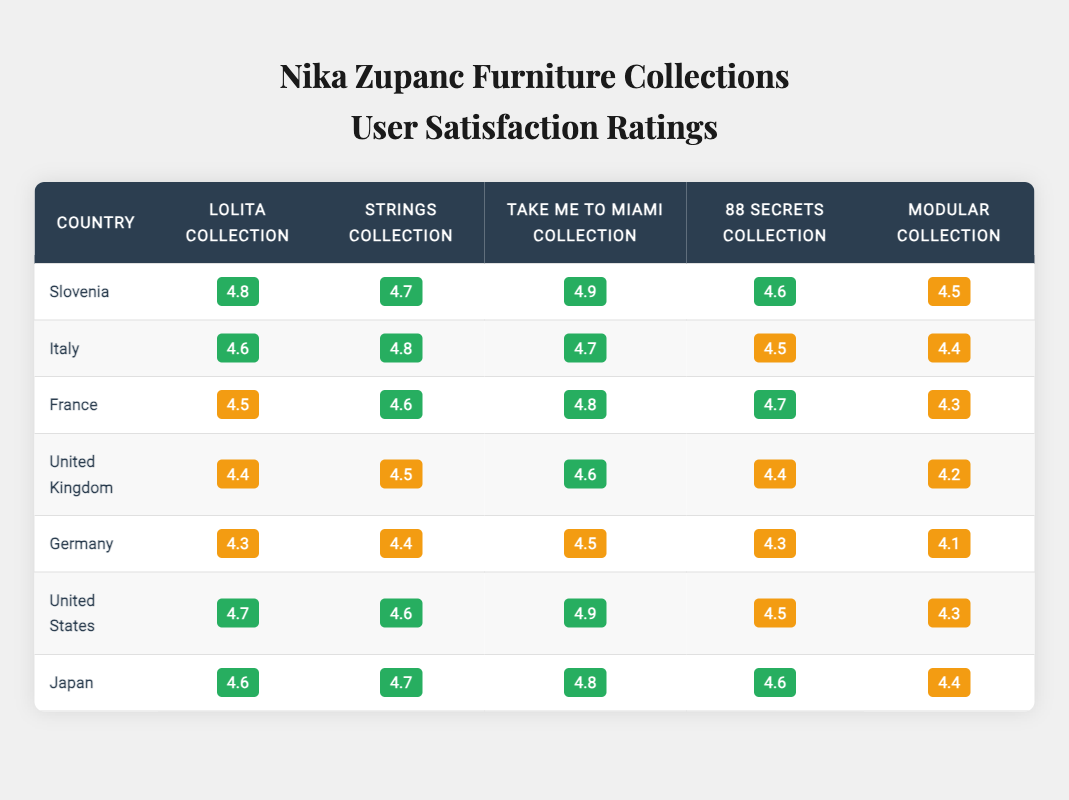What is the highest user satisfaction rating for the Lolita Collection? In the table, the ratings for the Lolita Collection across different countries are as follows: Slovenia (4.8), Italy (4.6), France (4.5), United Kingdom (4.4), Germany (4.3), United States (4.7), and Japan (4.6). The highest rating is 4.9, which is not listed for the Lolita Collection in any country; hence, Slovenia holds the highest score at 4.8.
Answer: 4.8 Which collection has the highest rating in France? In the table, the ratings for the collections in France are: Lolita Collection (4.5), Strings Collection (4.6), Take Me to Miami Collection (4.8), 88 Secrets Collection (4.7), and Modular Collection (4.3). The highest rating among these is the Take Me to Miami Collection with a score of 4.8.
Answer: Take Me to Miami Collection Is the user satisfaction rating for the Modular Collection in Germany higher than in the United Kingdom? The ratings for the Modular Collection are as follows: Germany (4.1) and United Kingdom (4.2). Since 4.1 is less than 4.2, the rating for the Modular Collection in Germany is not higher than in the United Kingdom.
Answer: No What is the average rating of the Strings Collection across all countries? The ratings for the Strings Collection are: Slovenia (4.7), Italy (4.8), France (4.6), United Kingdom (4.5), Germany (4.4), United States (4.6), and Japan (4.7). Summing these gives 4.7 + 4.8 + 4.6 + 4.5 + 4.4 + 4.6 + 4.7 = 32.3. There are 7 ratings, so the average is 32.3 / 7 ≈ 4.61.
Answer: 4.61 Which country has the lowest rating for the 88 Secrets Collection? Reviewing the ratings for the 88 Secrets Collection: Slovenia (4.6), Italy (4.5), France (4.7), United Kingdom (4.4), Germany (4.3), United States (4.5), and Japan (4.6), Germany has the lowest rating at 4.3.
Answer: Germany In which country did the Take Me to Miami Collection receive the highest rating? The ratings for the Take Me to Miami Collection are: Slovenia (4.9), Italy (4.7), France (4.8), United Kingdom (4.6), Germany (4.5), United States (4.9), and Japan (4.8). The highest rating, 4.9, appears for both Slovenia and the United States.
Answer: Slovenia and United States 